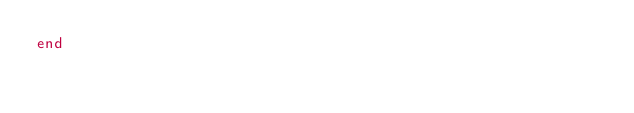<code> <loc_0><loc_0><loc_500><loc_500><_Ruby_>end
</code> 